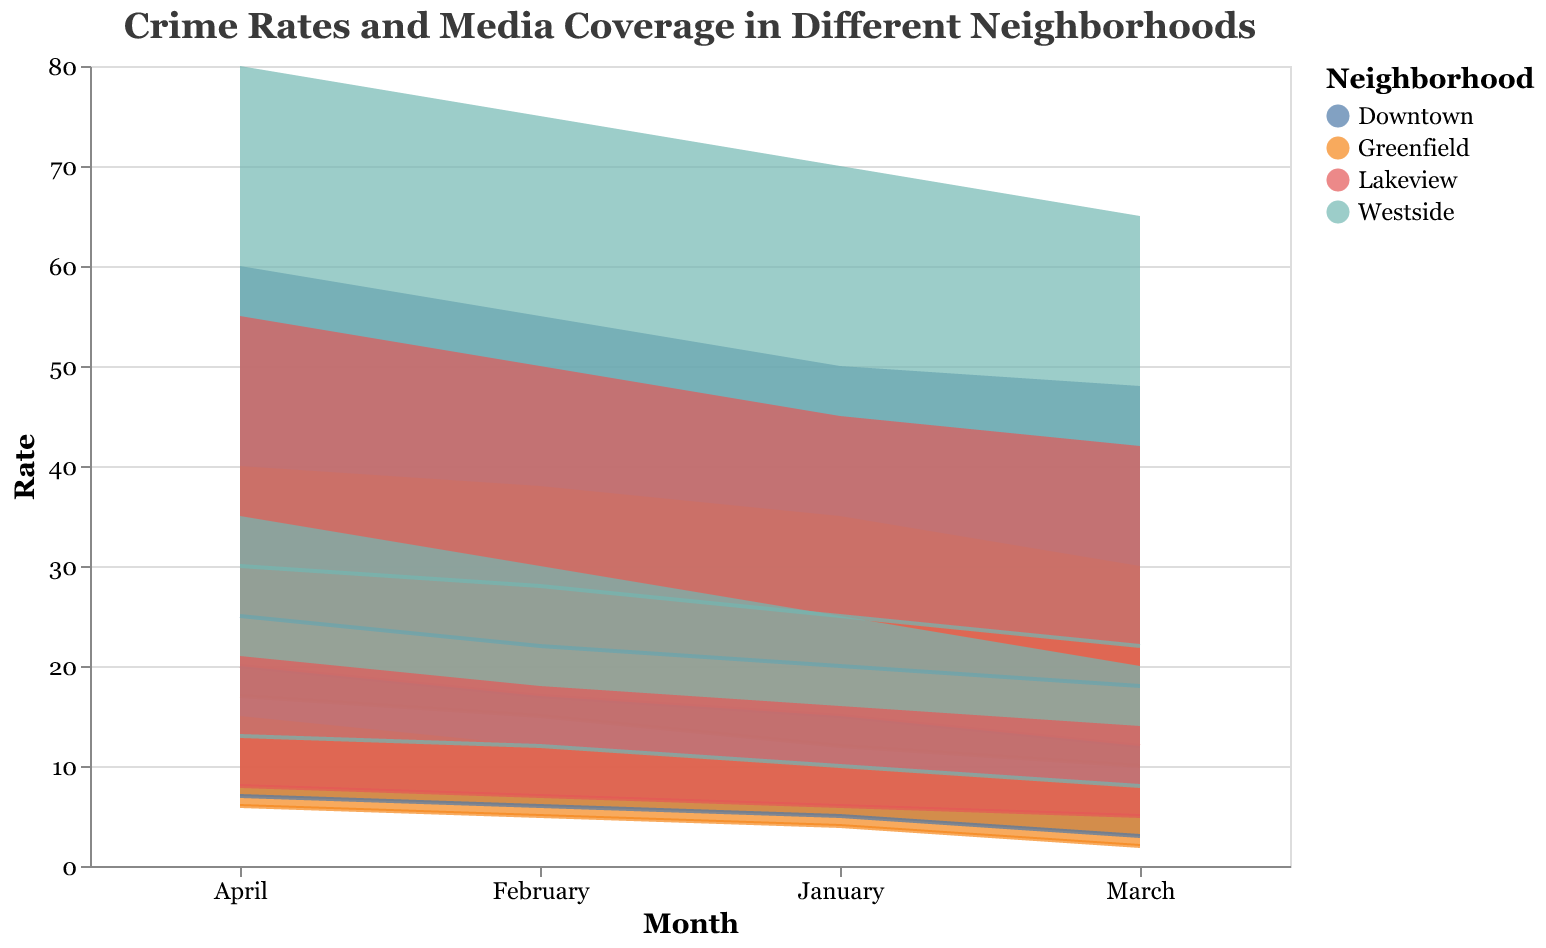What neighborhood has the highest crime rate range in April? In April, the crime rate range for Westside is from 30 to 80, which is the highest among all neighborhoods for that month.
Answer: Westside Which neighborhood consistently has the lowest media coverage across all months? By comparing the ranges of media coverage across all months, Greenfield has the lowest media coverage range in January (4-10), February (5-12), March (2-8), and April (6-15).
Answer: Greenfield Does the crime rate trend upwards or downwards for Downtown from January to April? Observing the visualization for Downtown, the crime rate generally trends upwards from January (20-50) to April (25-60).
Answer: Upwards Which neighborhood exhibits the largest difference in media coverage between March and April? Comparing the difference in media coverage between March and April for all neighborhoods, Westside shows the largest increase from March (8-20) to April (13-35).
Answer: Westside What is the crime range difference between Downtown and Greenfield in February? In February, Downtown has a crime range of 22-55, and Greenfield has a range of 15-38. The difference between their high values is 55-38=17 and low values is 22-15=7. Hence, the difference range is 7-17.
Answer: 7-17 Do higher crime rates correlate with higher media coverage in Lakeview? Comparing the trends for crime rates and media coverage in Lakeview from January to April, when the crime rate increases (15-45 to 20-55), media coverage also increases (6-16 to 8-21), suggesting a correlation.
Answer: Yes Which month shows the highest crime rate range across all neighborhoods? By assessing the crime rate ranges for all neighborhoods across each month, April shows the highest overall range, particularly due to Westside's range of 30-80.
Answer: April Between which months does Westside see the most significant increase in crime rate? Westside's crime rate increases from January (25-70) to February (28-75). The most significant change is from March (22-65) to April (30-80).
Answer: March to April Which neighborhood sees the most consistent crime rate range across all months? Evaluating the consistency of crime rate ranges across all months, Downtown's range remains relatively stable, fluctuating minimally between (18-48) and (25-60).
Answer: Downtown What is the average media coverage high value in Greenfield during the first three months? Adding the high values of media coverage for Greenfield from January (10), February (12), and March (8): 10+12+8=30. Dividing by 3, the average is 30/3 = 10.
Answer: 10 